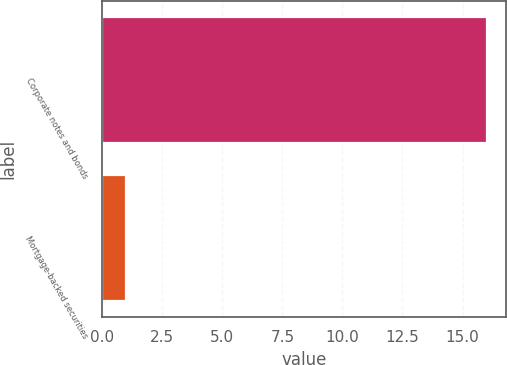<chart> <loc_0><loc_0><loc_500><loc_500><bar_chart><fcel>Corporate notes and bonds<fcel>Mortgage-backed securities<nl><fcel>16<fcel>1<nl></chart> 